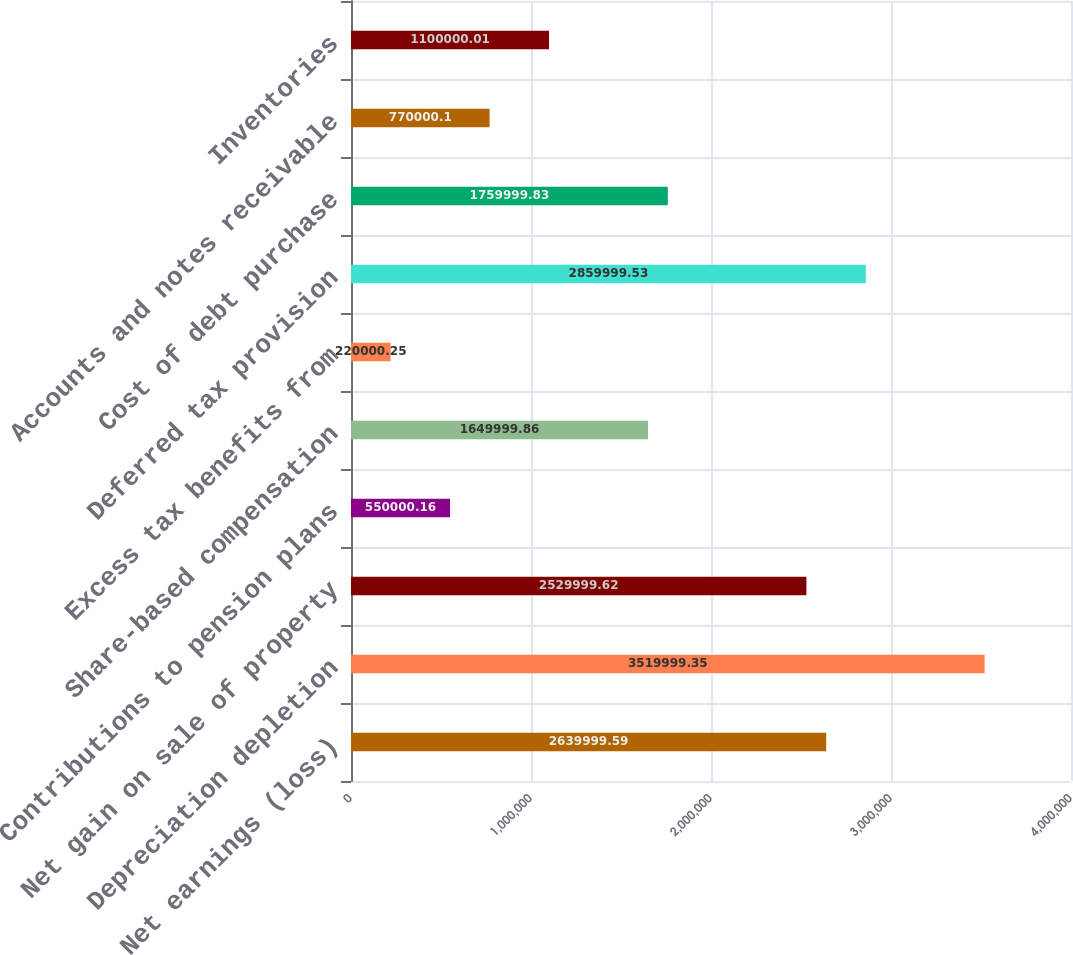Convert chart. <chart><loc_0><loc_0><loc_500><loc_500><bar_chart><fcel>Net earnings (loss)<fcel>Depreciation depletion<fcel>Net gain on sale of property<fcel>Contributions to pension plans<fcel>Share-based compensation<fcel>Excess tax benefits from<fcel>Deferred tax provision<fcel>Cost of debt purchase<fcel>Accounts and notes receivable<fcel>Inventories<nl><fcel>2.64e+06<fcel>3.52e+06<fcel>2.53e+06<fcel>550000<fcel>1.65e+06<fcel>220000<fcel>2.86e+06<fcel>1.76e+06<fcel>770000<fcel>1.1e+06<nl></chart> 